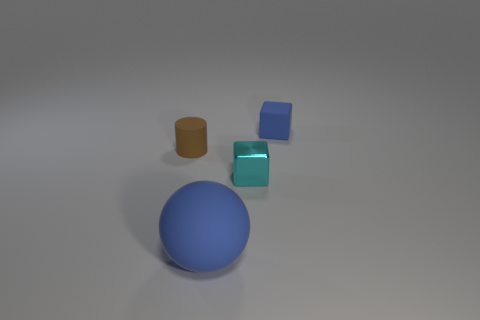Is there any object in the image that could float on water? Without specific material properties it's difficult to be certain, but traditionally, spheres and cylinders made of materials like plastic or rubber are common floatable shapes due to their displacement of water if they are hollow or lightweight.  Which objects in the image appear to be the most reflective? The tiny cyan cube appears to be the most reflective among the objects due to the visible sheen and the clear highlights on its surfaces. 